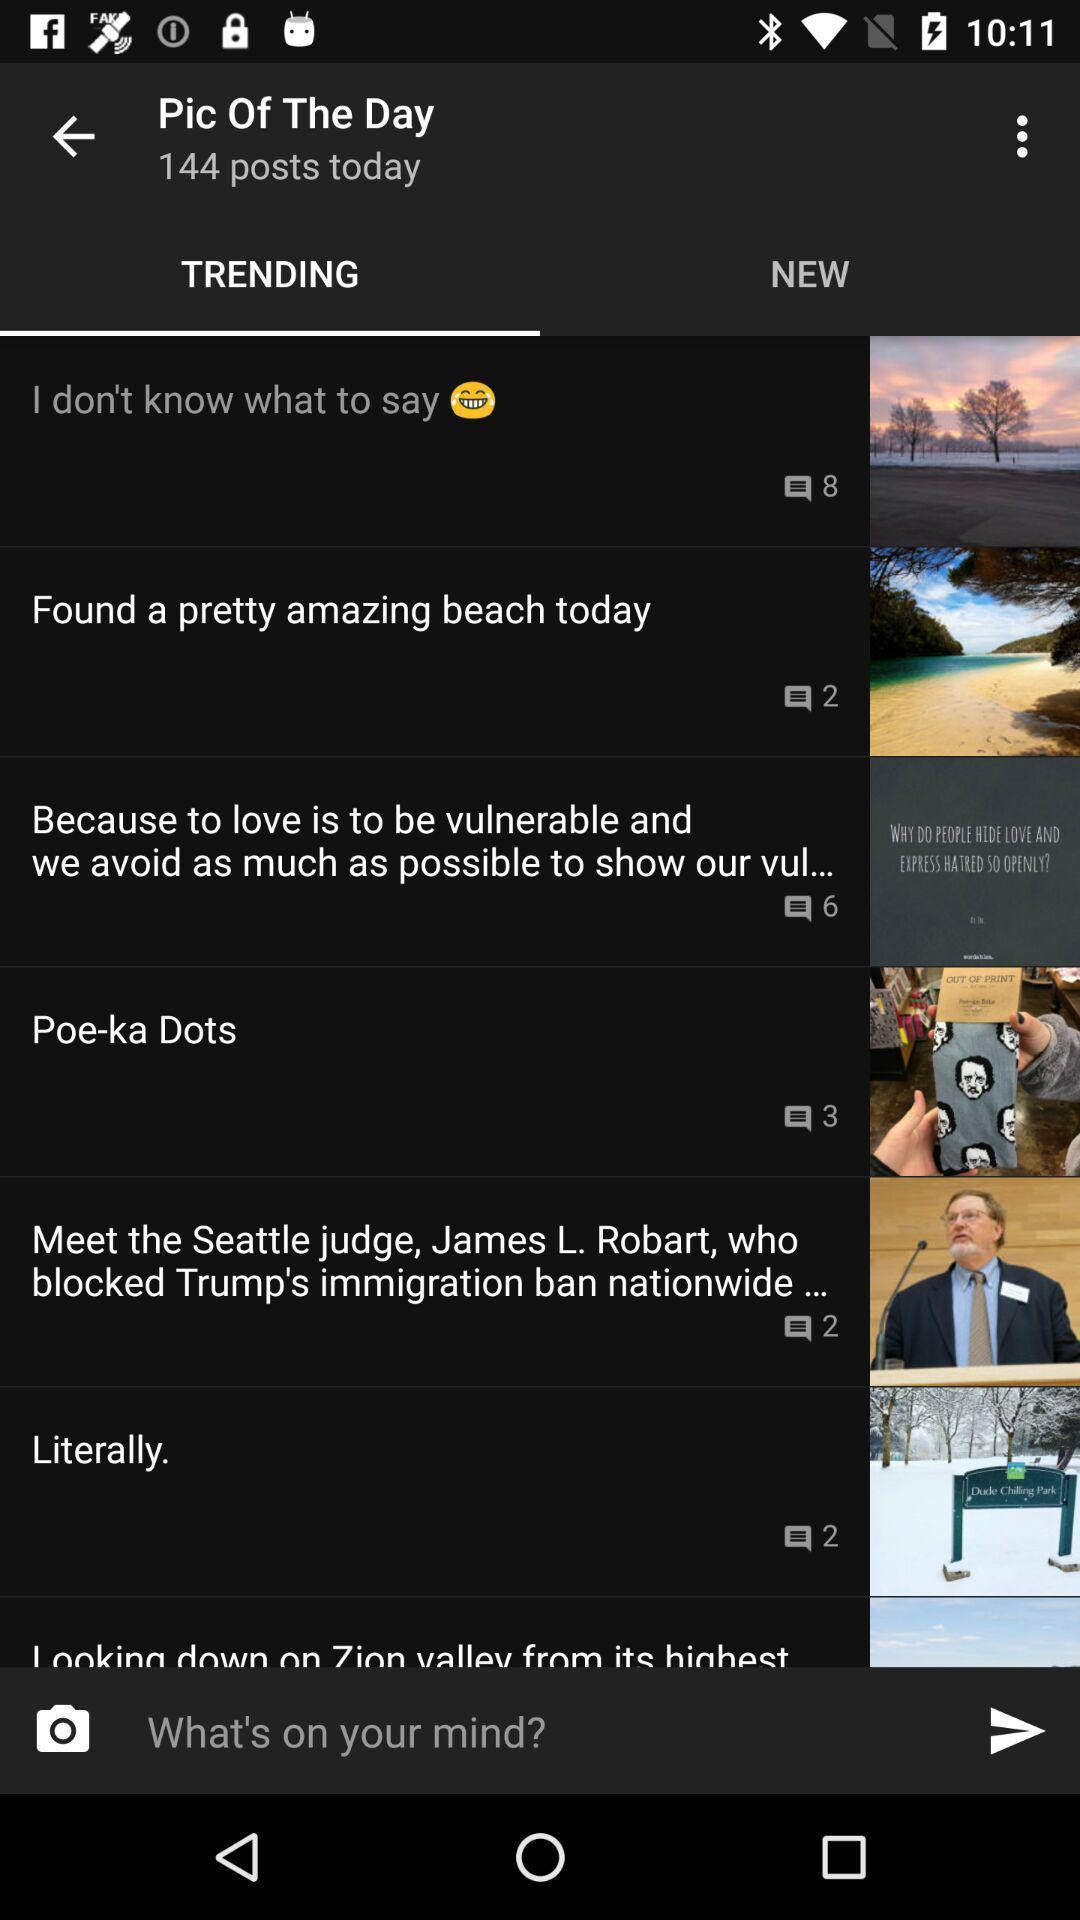Provide a detailed account of this screenshot. Trending articles page. 